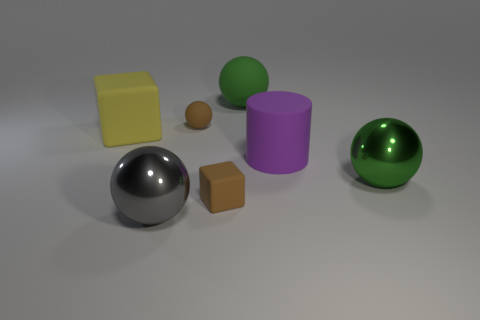Add 2 large matte balls. How many objects exist? 9 Subtract all cylinders. How many objects are left? 6 Subtract 1 yellow blocks. How many objects are left? 6 Subtract all tiny objects. Subtract all green matte spheres. How many objects are left? 4 Add 6 big blocks. How many big blocks are left? 7 Add 6 small matte balls. How many small matte balls exist? 7 